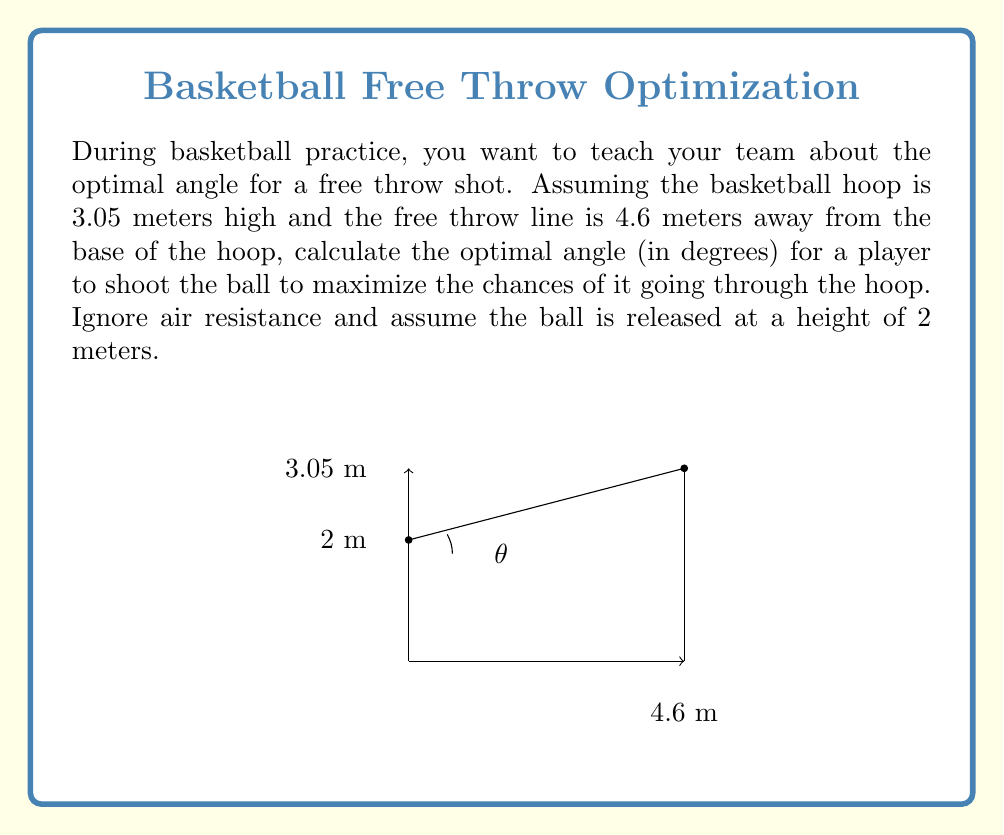Show me your answer to this math problem. To find the optimal angle for a free throw shot, we need to use principles from projectile motion. The optimal angle maximizes the range for a given initial velocity. In this case, we're not concerned with the initial velocity, but rather finding the angle that requires the minimum initial velocity to reach the target.

Let's approach this step-by-step:

1) First, we need to find the horizontal and vertical distances the ball needs to travel:
   Horizontal distance: $x = 4.6$ m
   Vertical distance: $y = 3.05 - 2 = 1.05$ m (since the ball is released at 2 m height)

2) The optimal angle for projectile motion is given by the formula:

   $$\theta = \arctan(\frac{y}{x})$$

3) Substituting our values:

   $$\theta = \arctan(\frac{1.05}{4.6})$$

4) Calculate:

   $$\theta = \arctan(0.2282609)$$

5) Convert to degrees:

   $$\theta = 12.85^\circ$$

This angle provides the optimal trajectory for the ball to reach the hoop with the minimum required initial velocity, thus maximizing the chances of a successful shot.
Answer: The optimal angle for a free throw shot under the given conditions is approximately $12.85^\circ$. 